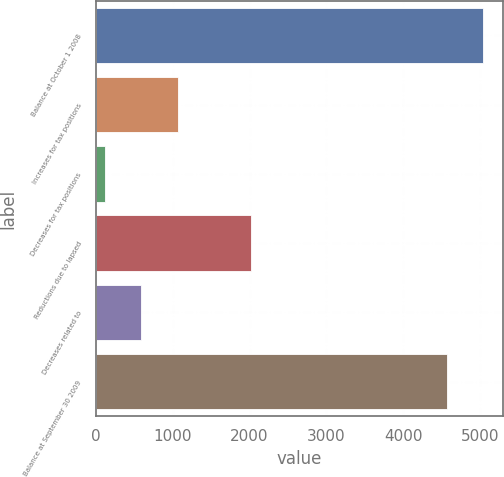Convert chart to OTSL. <chart><loc_0><loc_0><loc_500><loc_500><bar_chart><fcel>Balance at October 1 2008<fcel>Increases for tax positions<fcel>Decreases for tax positions<fcel>Reductions due to lapsed<fcel>Decreases related to<fcel>Balance at September 30 2009<nl><fcel>5039.8<fcel>1063.6<fcel>114<fcel>2013.2<fcel>588.8<fcel>4565<nl></chart> 